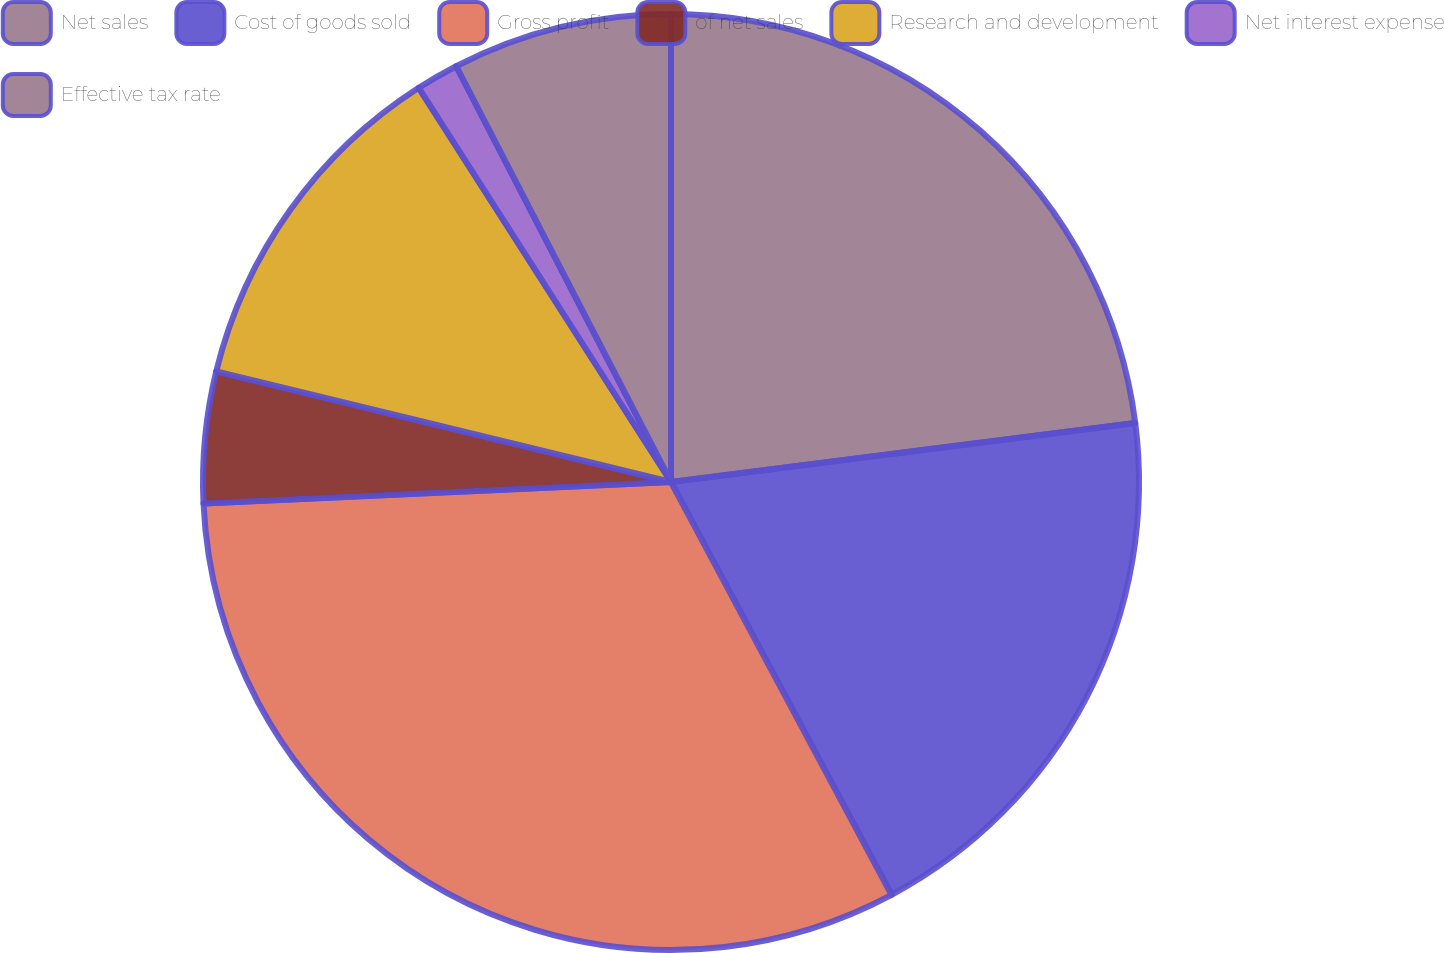<chart> <loc_0><loc_0><loc_500><loc_500><pie_chart><fcel>Net sales<fcel>Cost of goods sold<fcel>Gross profit<fcel>of net sales<fcel>Research and development<fcel>Net interest expense<fcel>Effective tax rate<nl><fcel>22.99%<fcel>19.2%<fcel>32.08%<fcel>4.53%<fcel>12.14%<fcel>1.47%<fcel>7.59%<nl></chart> 